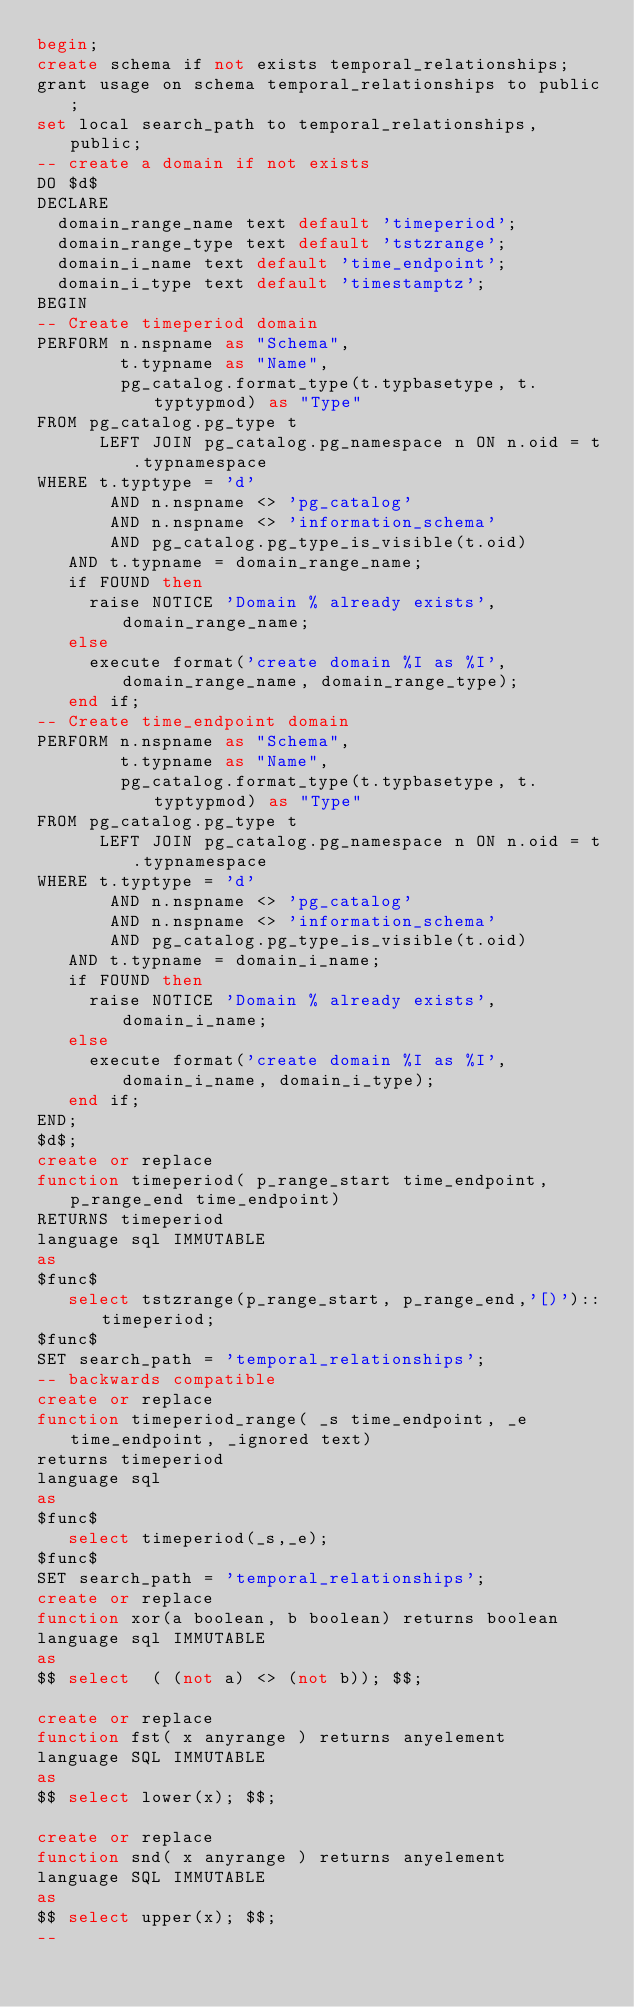Convert code to text. <code><loc_0><loc_0><loc_500><loc_500><_SQL_>begin;
create schema if not exists temporal_relationships;
grant usage on schema temporal_relationships to public;
set local search_path to temporal_relationships, public;
-- create a domain if not exists 
DO $d$
DECLARE
  domain_range_name text default 'timeperiod';
  domain_range_type text default 'tstzrange';
  domain_i_name text default 'time_endpoint';
  domain_i_type text default 'timestamptz';
BEGIN
-- Create timeperiod domain
PERFORM n.nspname as "Schema",
        t.typname as "Name",
        pg_catalog.format_type(t.typbasetype, t.typtypmod) as "Type"
FROM pg_catalog.pg_type t
      LEFT JOIN pg_catalog.pg_namespace n ON n.oid = t.typnamespace
WHERE t.typtype = 'd'
       AND n.nspname <> 'pg_catalog'
       AND n.nspname <> 'information_schema'
       AND pg_catalog.pg_type_is_visible(t.oid)
   AND t.typname = domain_range_name;
   if FOUND then
     raise NOTICE 'Domain % already exists', domain_range_name;
   else
     execute format('create domain %I as %I', domain_range_name, domain_range_type);
   end if;
-- Create time_endpoint domain
PERFORM n.nspname as "Schema",
        t.typname as "Name",
        pg_catalog.format_type(t.typbasetype, t.typtypmod) as "Type"
FROM pg_catalog.pg_type t
      LEFT JOIN pg_catalog.pg_namespace n ON n.oid = t.typnamespace
WHERE t.typtype = 'd'
       AND n.nspname <> 'pg_catalog'
       AND n.nspname <> 'information_schema'
       AND pg_catalog.pg_type_is_visible(t.oid)
   AND t.typname = domain_i_name;
   if FOUND then
     raise NOTICE 'Domain % already exists', domain_i_name;
   else
     execute format('create domain %I as %I', domain_i_name, domain_i_type);
   end if;
END;
$d$;
create or replace
function timeperiod( p_range_start time_endpoint, p_range_end time_endpoint)
RETURNS timeperiod
language sql IMMUTABLE
as
$func$
   select tstzrange(p_range_start, p_range_end,'[)')::timeperiod;
$func$
SET search_path = 'temporal_relationships';
-- backwards compatible
create or replace
function timeperiod_range( _s time_endpoint, _e time_endpoint, _ignored text)
returns timeperiod
language sql
as
$func$
   select timeperiod(_s,_e);
$func$
SET search_path = 'temporal_relationships';
create or replace 
function xor(a boolean, b boolean) returns boolean
language sql IMMUTABLE
as 
$$ select  ( (not a) <> (not b)); $$;

create or replace 
function fst( x anyrange ) returns anyelement
language SQL IMMUTABLE 
as
$$ select lower(x); $$;

create or replace
function snd( x anyrange ) returns anyelement
language SQL IMMUTABLE 
as
$$ select upper(x); $$;
--</code> 